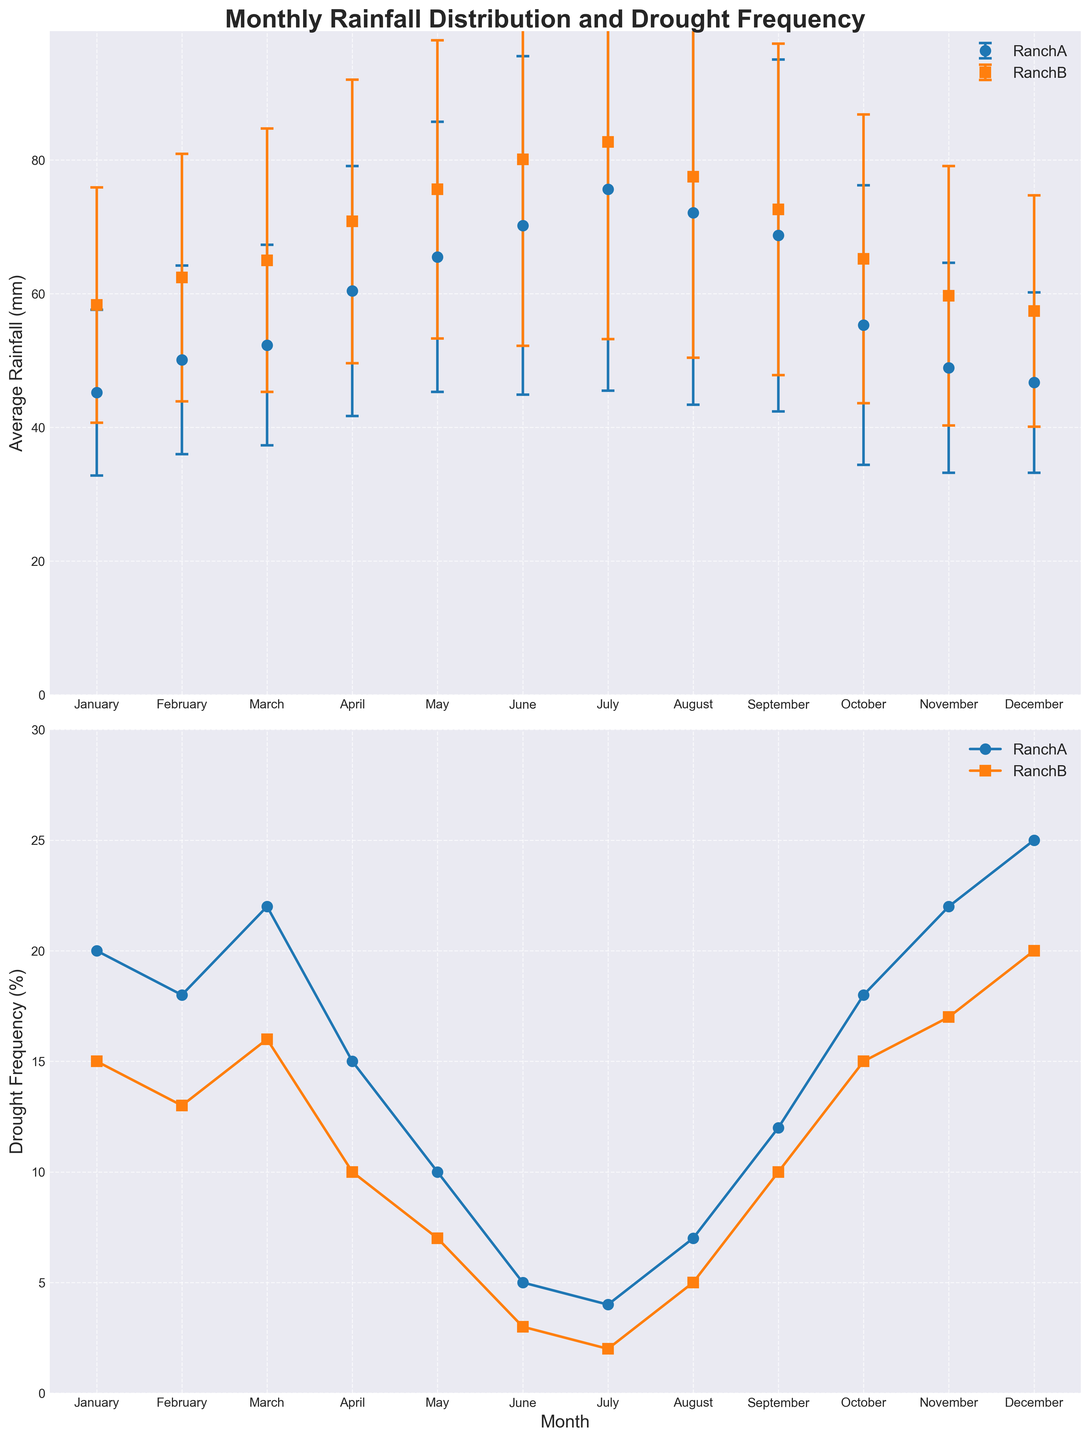What is the average rainfall in January for RanchA? The average rainfall for January in RanchA is displayed directly in the figure.
Answer: 45.2 mm How does the drought frequency in May compare between RanchA and RanchB? For RanchA, May's drought frequency is 10%. For RanchB, May's drought frequency is 7%. So, RanchA has a 3% higher drought frequency in May compared to RanchB.
Answer: RanchA has a 3% higher drought frequency Which month has the highest average rainfall at RanchB? By observing the plot, the month with the highest average rainfall at RanchB is easily identified as July with the highest point on its line.
Answer: July What is the range of average rainfall for RanchA? To find the range, subtract the minimum average rainfall (January: 45.2 mm) from the maximum average rainfall (July: 75.6 mm). The range is 75.6 mm - 45.2 mm = 30.4 mm.
Answer: 30.4 mm Which month shows the greatest variability in rainfall for RanchA? Variability in rainfall is indicated by the length of the error bars. The month with the largest error bar is July, showing the greatest variability.
Answer: July How does the average rainfall in April compare between RanchA and RanchB? In April, RanchA has around 60.4 mm of rainfall and RanchB has around 70.8 mm. RanchB has approximately 10.4 mm more rainfall in April than RanchA.
Answer: RanchB receives 10.4 mm more rainfall What is the trend in drought frequency from June to August for RanchA? Observing the line plot for RanchA from June to August, drought frequency increases from 5% to 7%, indicating an upward trend.
Answer: Upward trend What is the difference in drought frequency for RanchA between the driest and wettest month? July has the highest average rainfall (75.6 mm) and May has the lowest drought frequency (10%). December has the highest drought frequency (25%) with an average rainfall of 46.7 mm. The difference in drought frequency is 25% - 4% = 21%.
Answer: 21% In which month do RanchA and RanchB have the closest average rainfall? By comparing the monthly average rainfall values, January shows the closest average rainfall between RanchA (45.2 mm) and RanchB (58.3 mm), which is a difference of 13.1 mm.
Answer: January How do the error bars in January compare between RanchA and RanchB? January's error bar (standard deviation) for RanchA is 12.4 mm, while for RanchB, it is 17.6 mm. This indicates that RanchB has a larger variability in January rainfall than RanchA.
Answer: RanchB has larger error bars 